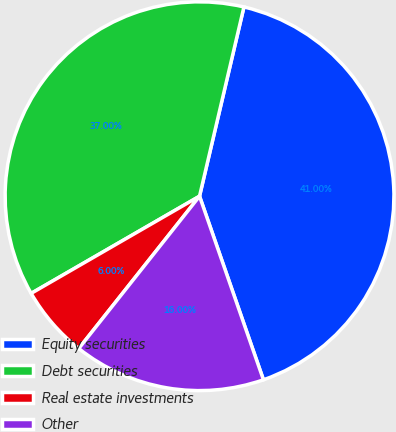<chart> <loc_0><loc_0><loc_500><loc_500><pie_chart><fcel>Equity securities<fcel>Debt securities<fcel>Real estate investments<fcel>Other<nl><fcel>41.0%<fcel>37.0%<fcel>6.0%<fcel>16.0%<nl></chart> 